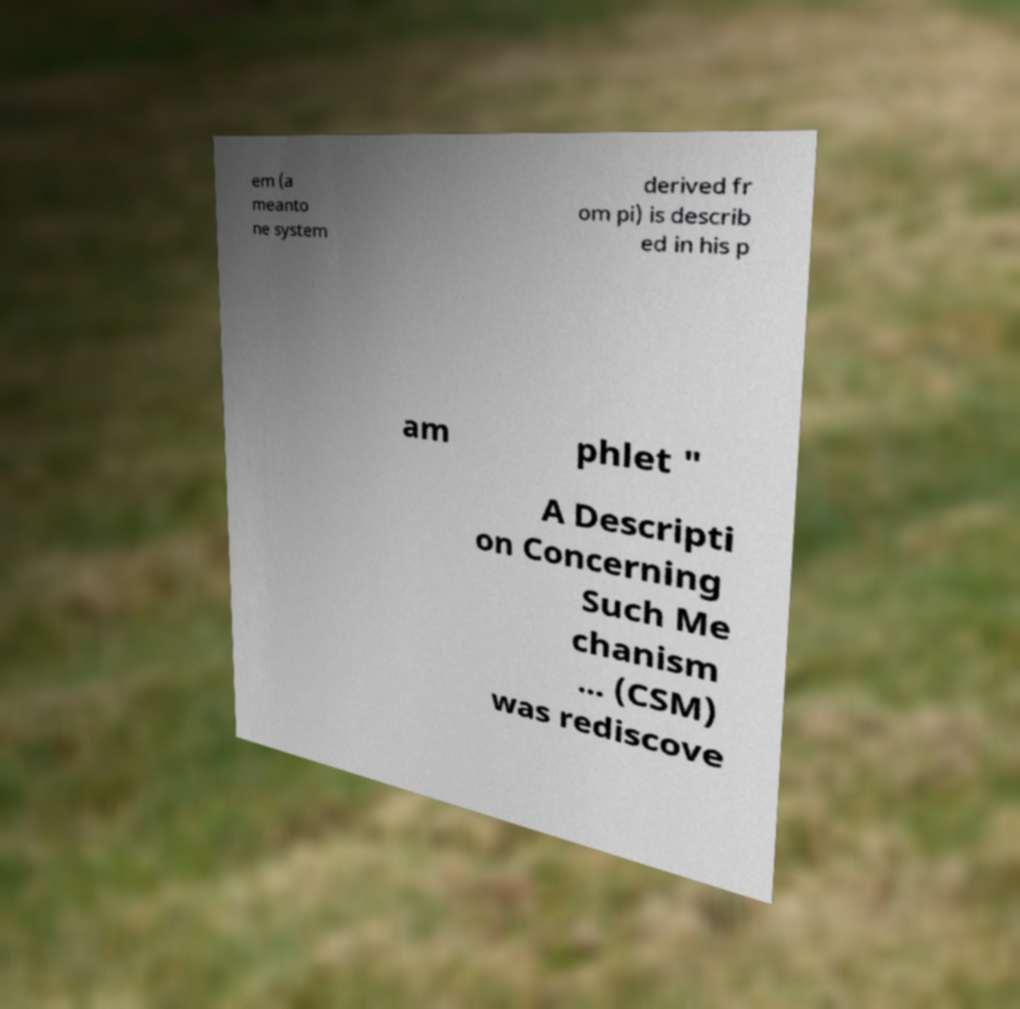There's text embedded in this image that I need extracted. Can you transcribe it verbatim? em (a meanto ne system derived fr om pi) is describ ed in his p am phlet " A Descripti on Concerning Such Me chanism ... (CSM) was rediscove 